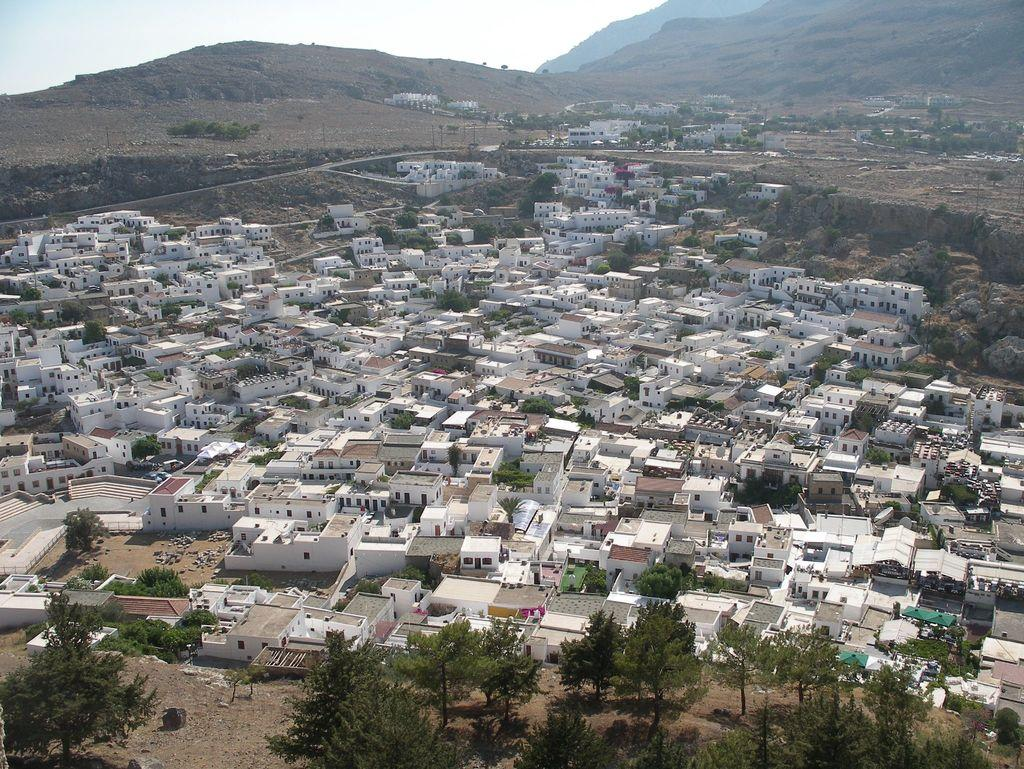What type of view is shown in the image? The image is an aerial view of a city. What natural elements can be seen in the image? There are trees visible in the image. What man-made structures are present in the image? There are buildings in the image. What geographical feature is visible at the back of the image? There are mountains at the back of the image. Can you tell me which actor is standing next to the cornfield in the image? There is no actor or cornfield present in the image; it is an aerial view of a city with trees, buildings, and mountains. 